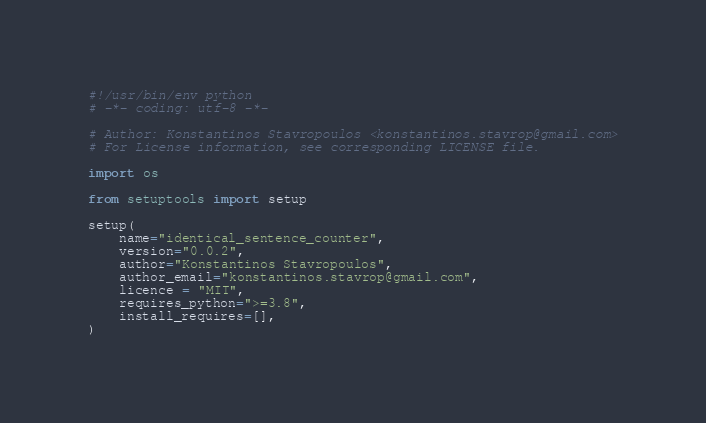Convert code to text. <code><loc_0><loc_0><loc_500><loc_500><_Python_>#!/usr/bin/env python
# -*- coding: utf-8 -*-

# Author: Konstantinos Stavropoulos <konstantinos.stavrop@gmail.com>
# For License information, see corresponding LICENSE file.

import os

from setuptools import setup

setup(
    name="identical_sentence_counter",
    version="0.0.2",
    author="Konstantinos Stavropoulos",
    author_email="konstantinos.stavrop@gmail.com",
    licence = "MIT",
    requires_python=">=3.8",
    install_requires=[],
)
</code> 